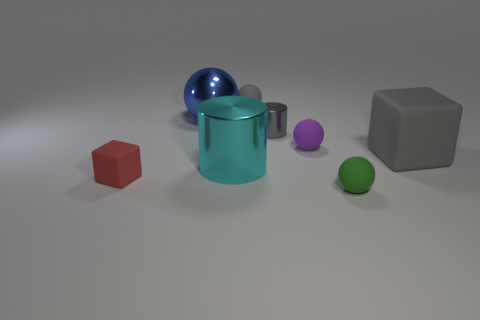Subtract 2 spheres. How many spheres are left? 2 Subtract all yellow spheres. Subtract all green blocks. How many spheres are left? 4 Add 1 big yellow shiny blocks. How many objects exist? 9 Subtract all cubes. How many objects are left? 6 Add 7 gray rubber cylinders. How many gray rubber cylinders exist? 7 Subtract 0 brown balls. How many objects are left? 8 Subtract all large blue things. Subtract all tiny balls. How many objects are left? 4 Add 2 big gray rubber cubes. How many big gray rubber cubes are left? 3 